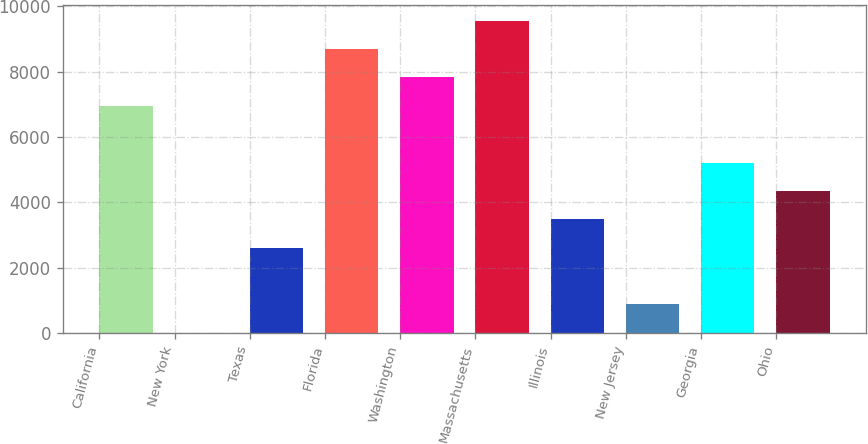<chart> <loc_0><loc_0><loc_500><loc_500><bar_chart><fcel>California<fcel>New York<fcel>Texas<fcel>Florida<fcel>Washington<fcel>Massachusetts<fcel>Illinois<fcel>New Jersey<fcel>Georgia<fcel>Ohio<nl><fcel>6951.8<fcel>3<fcel>2608.8<fcel>8689<fcel>7820.4<fcel>9557.6<fcel>3477.4<fcel>871.6<fcel>5214.6<fcel>4346<nl></chart> 